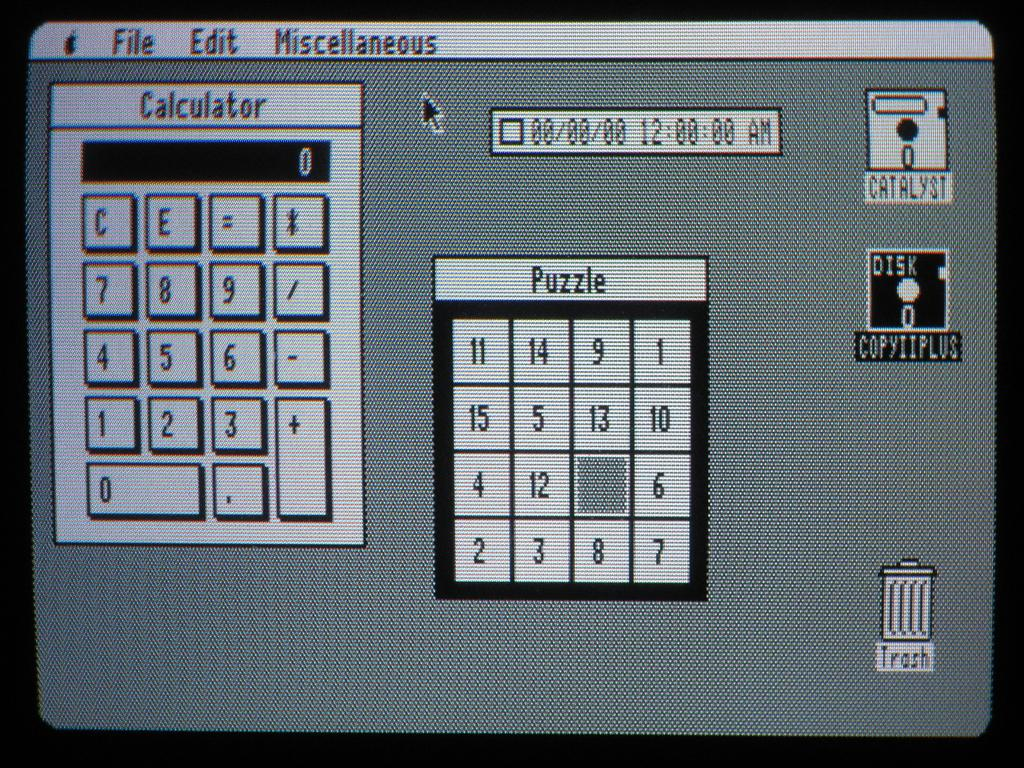What type of electronic device is associated with the monitor screen in the image? The monitor screen belongs to an electronic device, but the specific type is not mentioned in the facts. What is displayed on the monitor screen in the image? There is a calculator application and a puzzle application visible on the screen. Can you describe the applications visible on the monitor screen? The calculator application and the puzzle application are visible on the screen. What type of pie is being served on the grass in the image? There is no grass, pie, or pigs present in the image. 